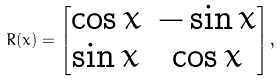<formula> <loc_0><loc_0><loc_500><loc_500>R ( x ) = \begin{bmatrix} \cos x & - \sin x \\ \sin x & \cos x \end{bmatrix} ,</formula> 